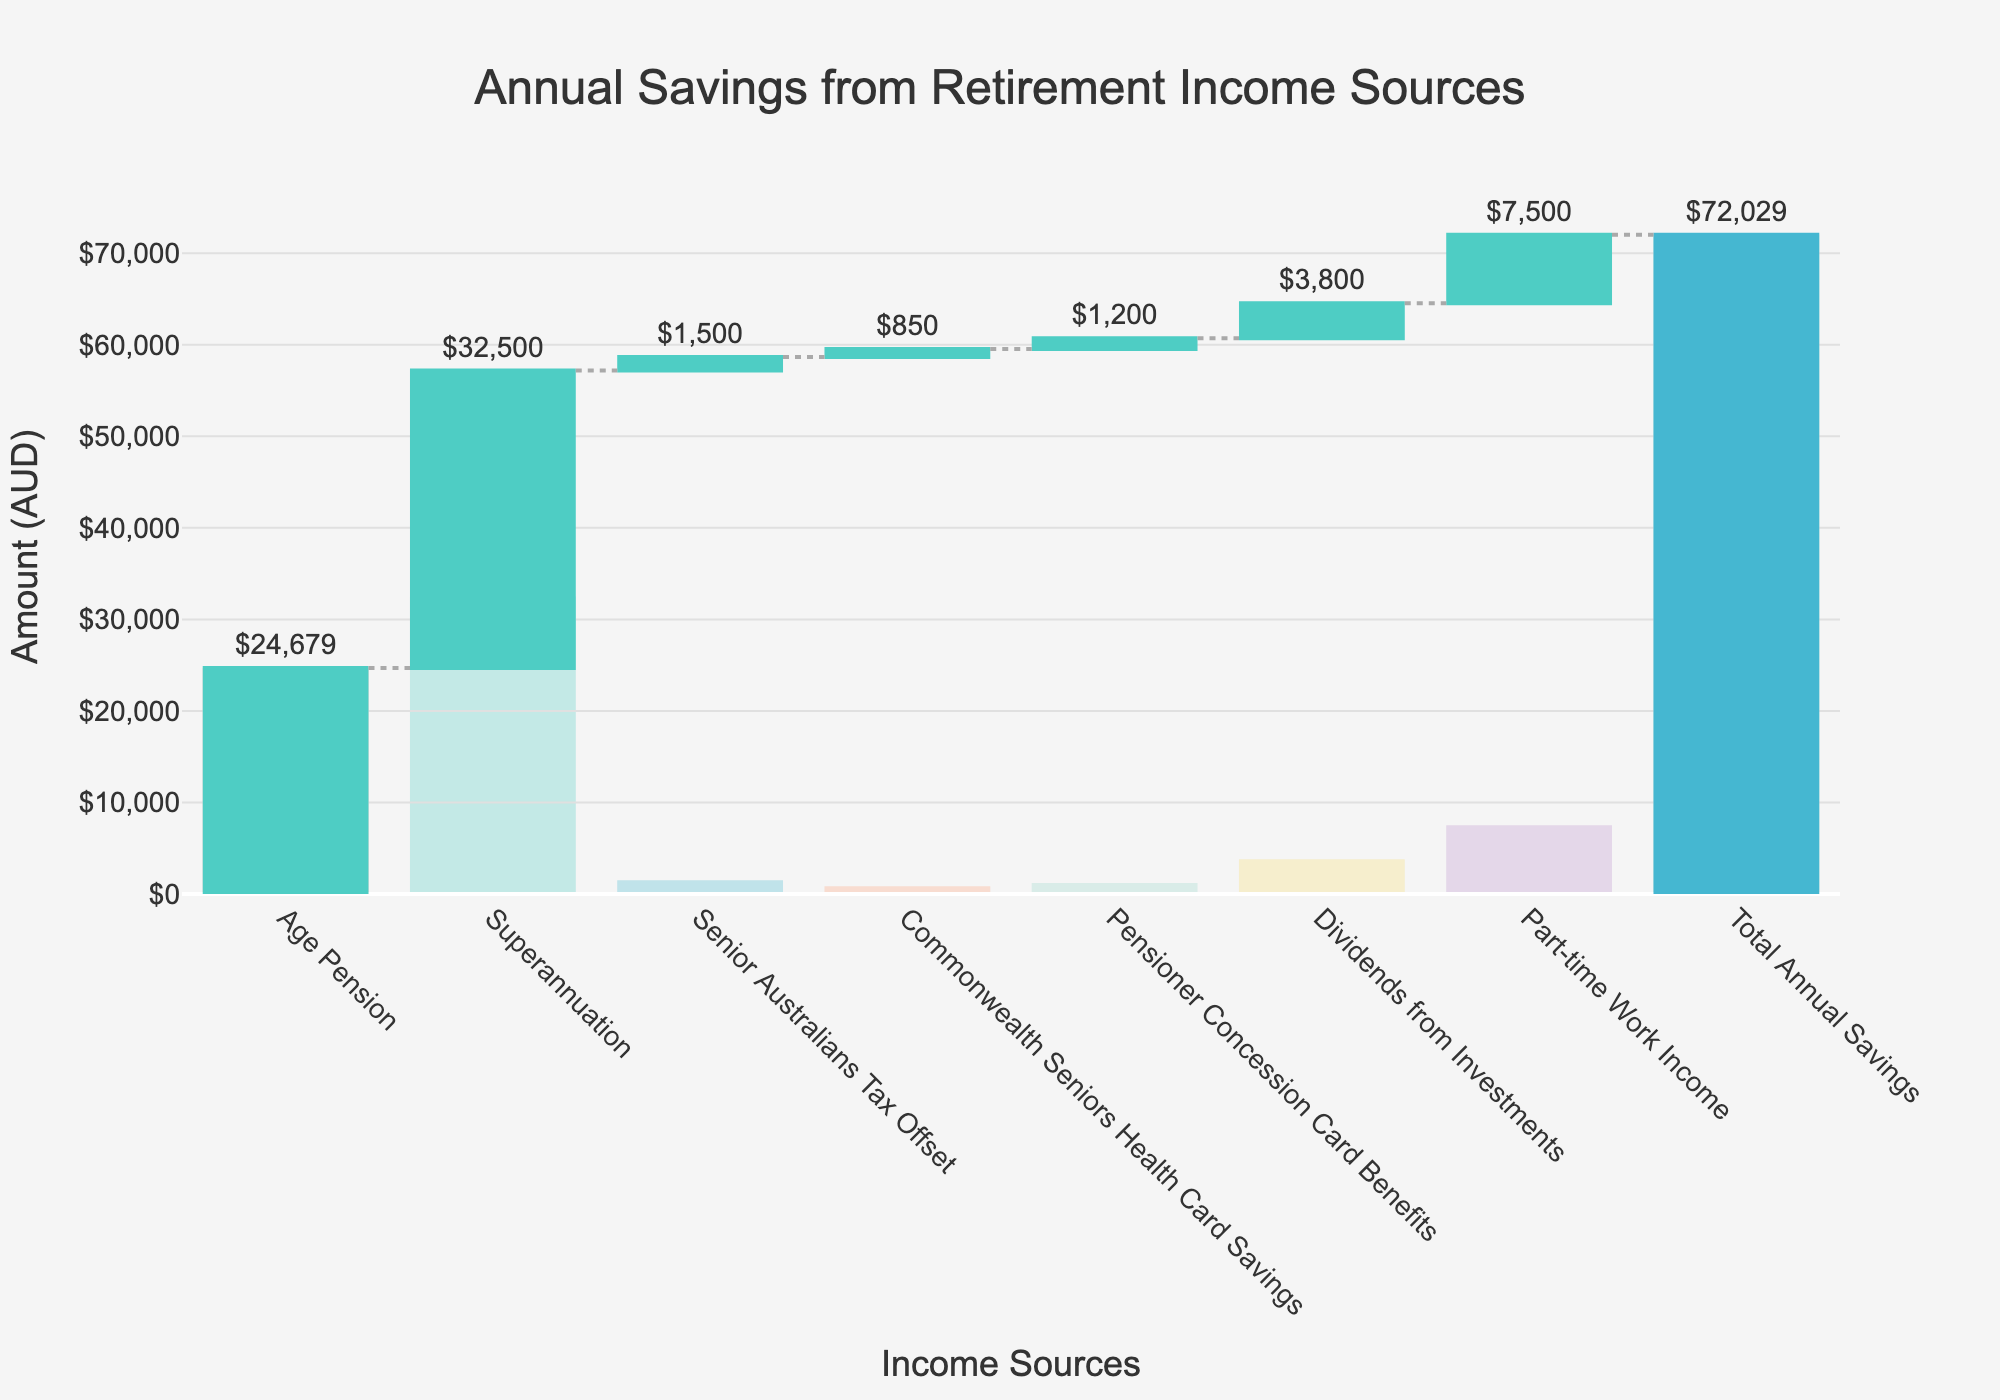What is the title of the figure? The title of the figure is located at the top and usually gives a clear description of what the chart represents. If you look at the top center of the chart, you'll see the title "Annual Savings from Retirement Income Sources".
Answer: Annual Savings from Retirement Income Sources What is the amount contributed by dividends from investments? The amount for each category is displayed either inside or above the bars. For "Dividends from Investments," the amount is shown as "$3,800" in the chart.
Answer: $3,800 Which category contributes the most to the total annual savings? Comparing all the categories by looking at the lengths of the bars, "Superannuation" has the longest bar representing the highest contribution of $32,500.
Answer: Superannuation How much more does superannuation contribute compared to age pension? Subtract the amount of Age Pension from the amount of Superannuation. Superannuation is $32,500 and Age Pension is $24,679. So the difference is $32,500 - $24,679 = $7,821.
Answer: $7,821 How much is the total annual savings shown in the figure? The total amount is displayed as one of the bars at the end of the chart, which combines all the previous contributions. The total annual savings is shown as $72,029.
Answer: $72,029 If the income from part-time work increased by 10%, what would be the new amount for that category? First find 10% of the part-time work income by multiplying $7,500 by 0.10. This gives $750. Adding this to the original amount, $7,500 + $750, results in a new amount of $8,250.
Answer: $8,250 How many income sources contribute to the total annual savings excluding the starting balance and total savings? By counting the number of categories listed on the x-axis excluding the starting balance and total savings, you get six income sources: Age Pension, Superannuation, Senior Australians Tax Offset, Commonwealth Seniors Health Card Savings, Pensioner Concession Card Benefits, Dividends from Investments, and Part-time Work Income.
Answer: 7 Which category contributes the least to the total annual savings? By looking at the bars, "Commonwealth Seniors Health Card Savings" has the smallest length, representing a contribution of $850.
Answer: Commonwealth Seniors Health Card Savings Does the category "Pensioner Concession Card Benefits" contribute more than "Dividends from Investments"? Compare the amounts: "Pensioner Concession Card Benefits" has $1,200 and "Dividends from Investments" has $3,800, so $1,200 < $3,800.
Answer: No 